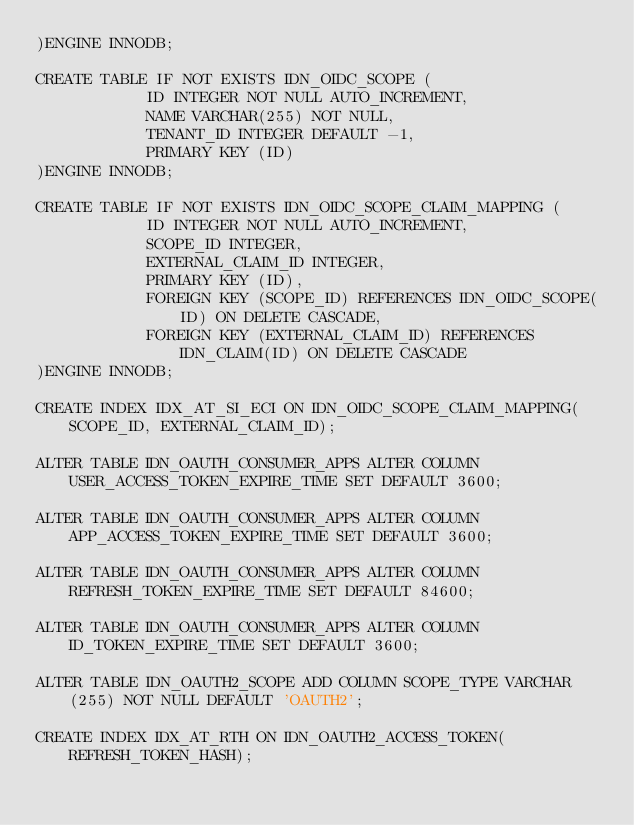<code> <loc_0><loc_0><loc_500><loc_500><_SQL_>)ENGINE INNODB;

CREATE TABLE IF NOT EXISTS IDN_OIDC_SCOPE (
            ID INTEGER NOT NULL AUTO_INCREMENT,
            NAME VARCHAR(255) NOT NULL,
            TENANT_ID INTEGER DEFAULT -1,
            PRIMARY KEY (ID)
)ENGINE INNODB;

CREATE TABLE IF NOT EXISTS IDN_OIDC_SCOPE_CLAIM_MAPPING (
            ID INTEGER NOT NULL AUTO_INCREMENT,
            SCOPE_ID INTEGER,
            EXTERNAL_CLAIM_ID INTEGER,
            PRIMARY KEY (ID),
            FOREIGN KEY (SCOPE_ID) REFERENCES IDN_OIDC_SCOPE(ID) ON DELETE CASCADE,
            FOREIGN KEY (EXTERNAL_CLAIM_ID) REFERENCES IDN_CLAIM(ID) ON DELETE CASCADE
)ENGINE INNODB;

CREATE INDEX IDX_AT_SI_ECI ON IDN_OIDC_SCOPE_CLAIM_MAPPING(SCOPE_ID, EXTERNAL_CLAIM_ID);

ALTER TABLE IDN_OAUTH_CONSUMER_APPS ALTER COLUMN USER_ACCESS_TOKEN_EXPIRE_TIME SET DEFAULT 3600;

ALTER TABLE IDN_OAUTH_CONSUMER_APPS ALTER COLUMN APP_ACCESS_TOKEN_EXPIRE_TIME SET DEFAULT 3600;

ALTER TABLE IDN_OAUTH_CONSUMER_APPS ALTER COLUMN REFRESH_TOKEN_EXPIRE_TIME SET DEFAULT 84600;

ALTER TABLE IDN_OAUTH_CONSUMER_APPS ALTER COLUMN ID_TOKEN_EXPIRE_TIME SET DEFAULT 3600;

ALTER TABLE IDN_OAUTH2_SCOPE ADD COLUMN SCOPE_TYPE VARCHAR(255) NOT NULL DEFAULT 'OAUTH2';

CREATE INDEX IDX_AT_RTH ON IDN_OAUTH2_ACCESS_TOKEN(REFRESH_TOKEN_HASH);</code> 